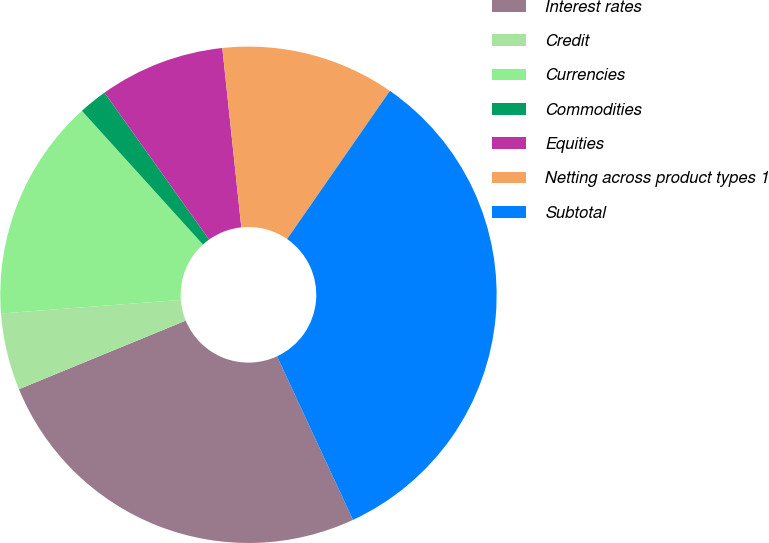Convert chart to OTSL. <chart><loc_0><loc_0><loc_500><loc_500><pie_chart><fcel>Interest rates<fcel>Credit<fcel>Currencies<fcel>Commodities<fcel>Equities<fcel>Netting across product types 1<fcel>Subtotal<nl><fcel>25.71%<fcel>5.01%<fcel>14.49%<fcel>1.86%<fcel>8.17%<fcel>11.33%<fcel>33.43%<nl></chart> 